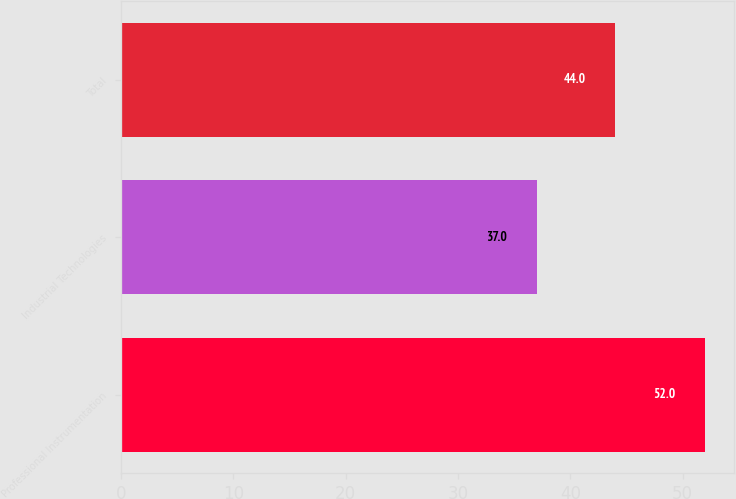Convert chart. <chart><loc_0><loc_0><loc_500><loc_500><bar_chart><fcel>Professional Instrumentation<fcel>Industrial Technologies<fcel>Total<nl><fcel>52<fcel>37<fcel>44<nl></chart> 